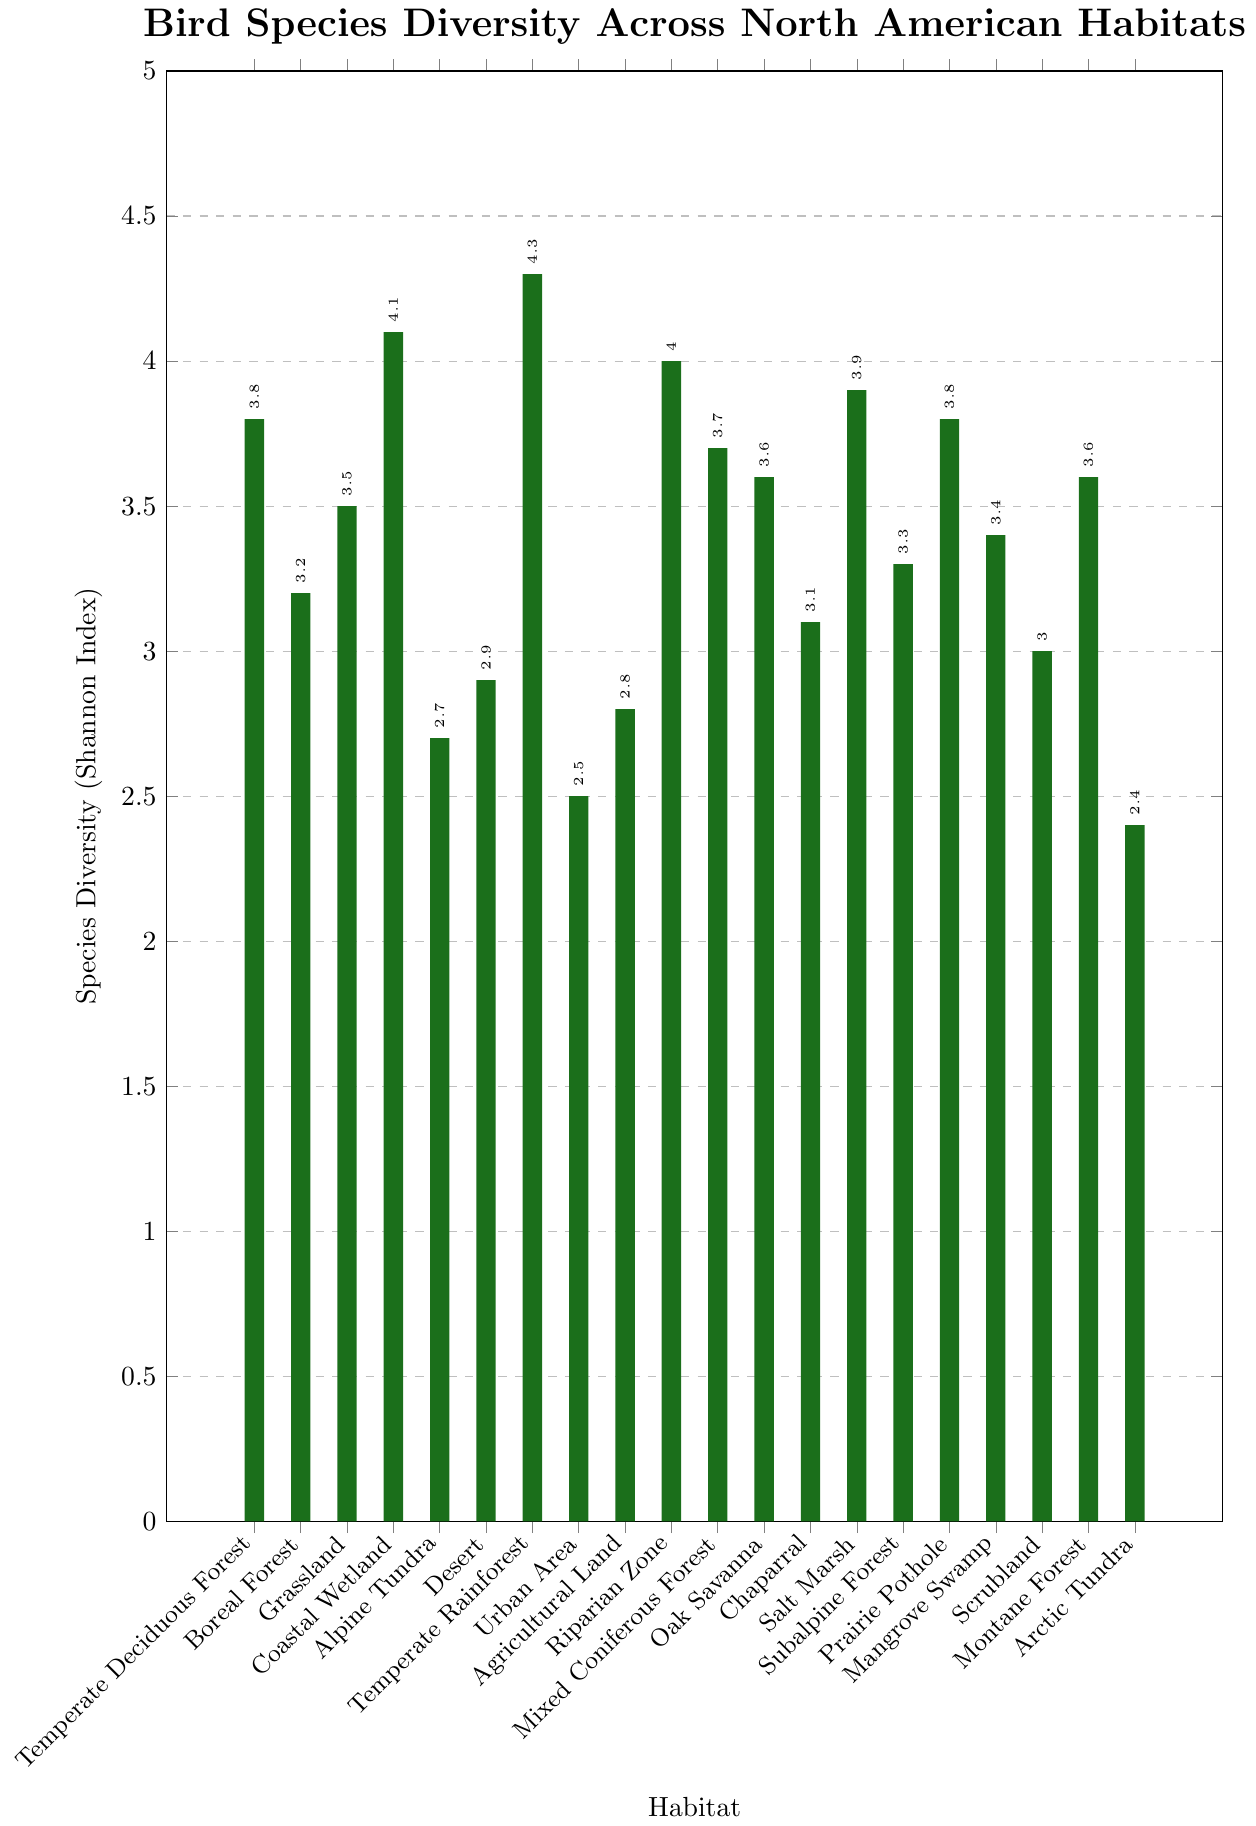What's the habitat with the highest bird species diversity? To find the habitat with the highest bird species diversity, locate the tallest bar in the chart. The tallest bar represents the Temperate Rainforest.
Answer: Temperate Rainforest Which habitat has lower bird species diversity, Desert or Subalpine Forest? To determine which habitat has lower bird species diversity between the Desert and Subalpine Forest, compare the heights of their respective bars. The Desert has a Shannon Index of 2.9, while the Subalpine Forest has a Shannon Index of 3.3. Therefore, the Desert has lower bird species diversity.
Answer: Desert What is the average species diversity for Urban Area, Agricultural Land, and Alpine Tundra? First, find the Shannon Index for each habitat: Urban Area (2.5), Agricultural Land (2.8), and Alpine Tundra (2.7). Then, sum these values: 2.5 + 2.8 + 2.7 = 8.0. Finally, divide by the number of habitats (3): 8.0 / 3 = 2.67.
Answer: 2.67 How much greater is the species diversity in the Coastal Wetland compared to the Arctic Tundra? The species diversity (Shannon Index) for Coastal Wetland is 4.1, and for Arctic Tundra, it is 2.4. Subtract the Shannon Index of Arctic Tundra from Coastal Wetland: 4.1 - 2.4 = 1.7.
Answer: 1.7 Identify the range of species diversity values in the data set. The range is the difference between the highest and lowest values in the dataset. The highest value is 4.3 (Temperate Rainforest), and the lowest is 2.4 (Arctic Tundra). Subtract the lowest value from the highest: 4.3 - 2.4 = 1.9.
Answer: 1.9 Which two habitats have the same species diversity of 3.6? Look for bars with the same height corresponding to a Shannon Index of 3.6. The habitats Oak Savanna and Montane Forest both have this species diversity value.
Answer: Oak Savanna and Montane Forest How does species diversity in Grassland compare to that in Mangrove Swamp? The Shannon Index for Grassland is 3.5, while for Mangrove Swamp it is 3.4. Grassland has a slightly higher species diversity than Mangrove Swamp.
Answer: Grassland What is the median species diversity value for all the habitats? First, list all the Shannon Index values in ascending order: 2.4, 2.5, 2.7, 2.8, 2.9, 3.0, 3.1, 3.2, 3.3, 3.4, 3.5, 3.6, 3.6, 3.7, 3.8, 3.8, 3.9, 4.0, 4.1, 4.3. Since there are 20 values, the median is the average of the 10th and 11th values: (3.4 + 3.5) / 2 = 3.45.
Answer: 3.45 What is the difference in species diversity between Temperate Deciduous Forest and Riparian Zone? The Shannon Index for Temperate Deciduous Forest is 3.8, and for Riparian Zone, it is 4.0. Subtract 3.8 from 4.0 to get the difference: 4.0 - 3.8 = 0.2.
Answer: 0.2 